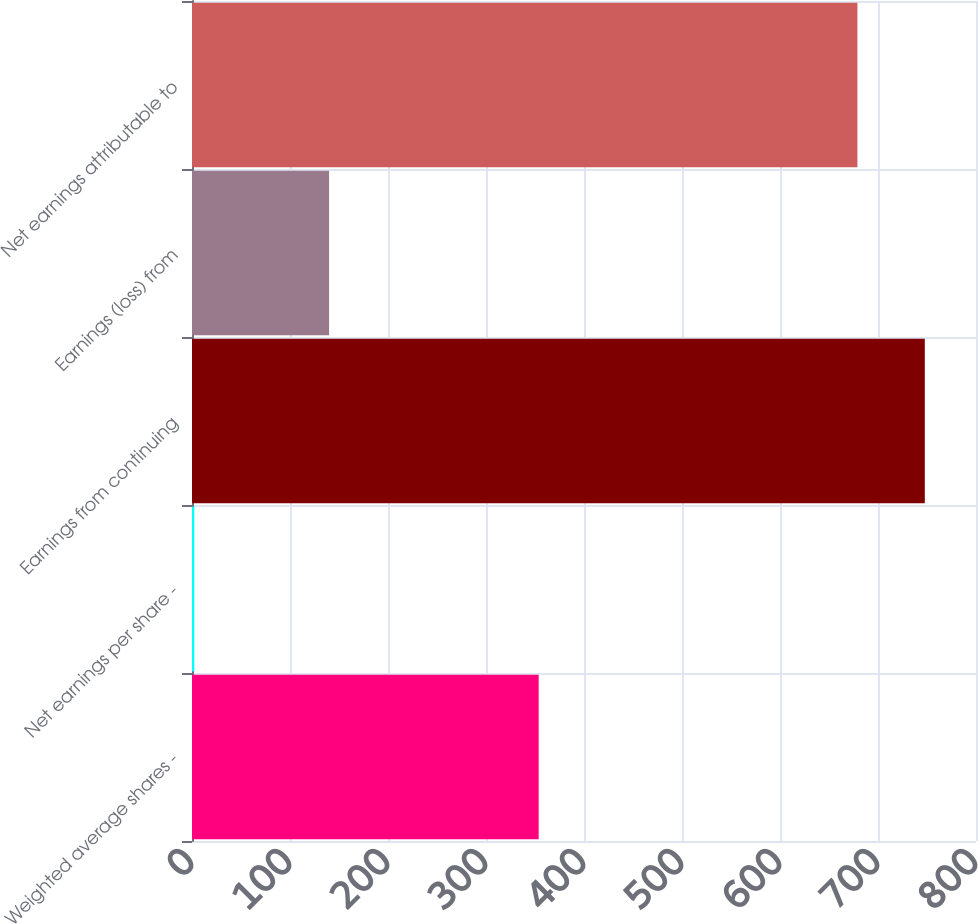Convert chart. <chart><loc_0><loc_0><loc_500><loc_500><bar_chart><fcel>Weighted average shares -<fcel>Net earnings per share -<fcel>Earnings from continuing<fcel>Earnings (loss) from<fcel>Net earnings attributable to<nl><fcel>353.76<fcel>2.35<fcel>747.76<fcel>139.88<fcel>679<nl></chart> 